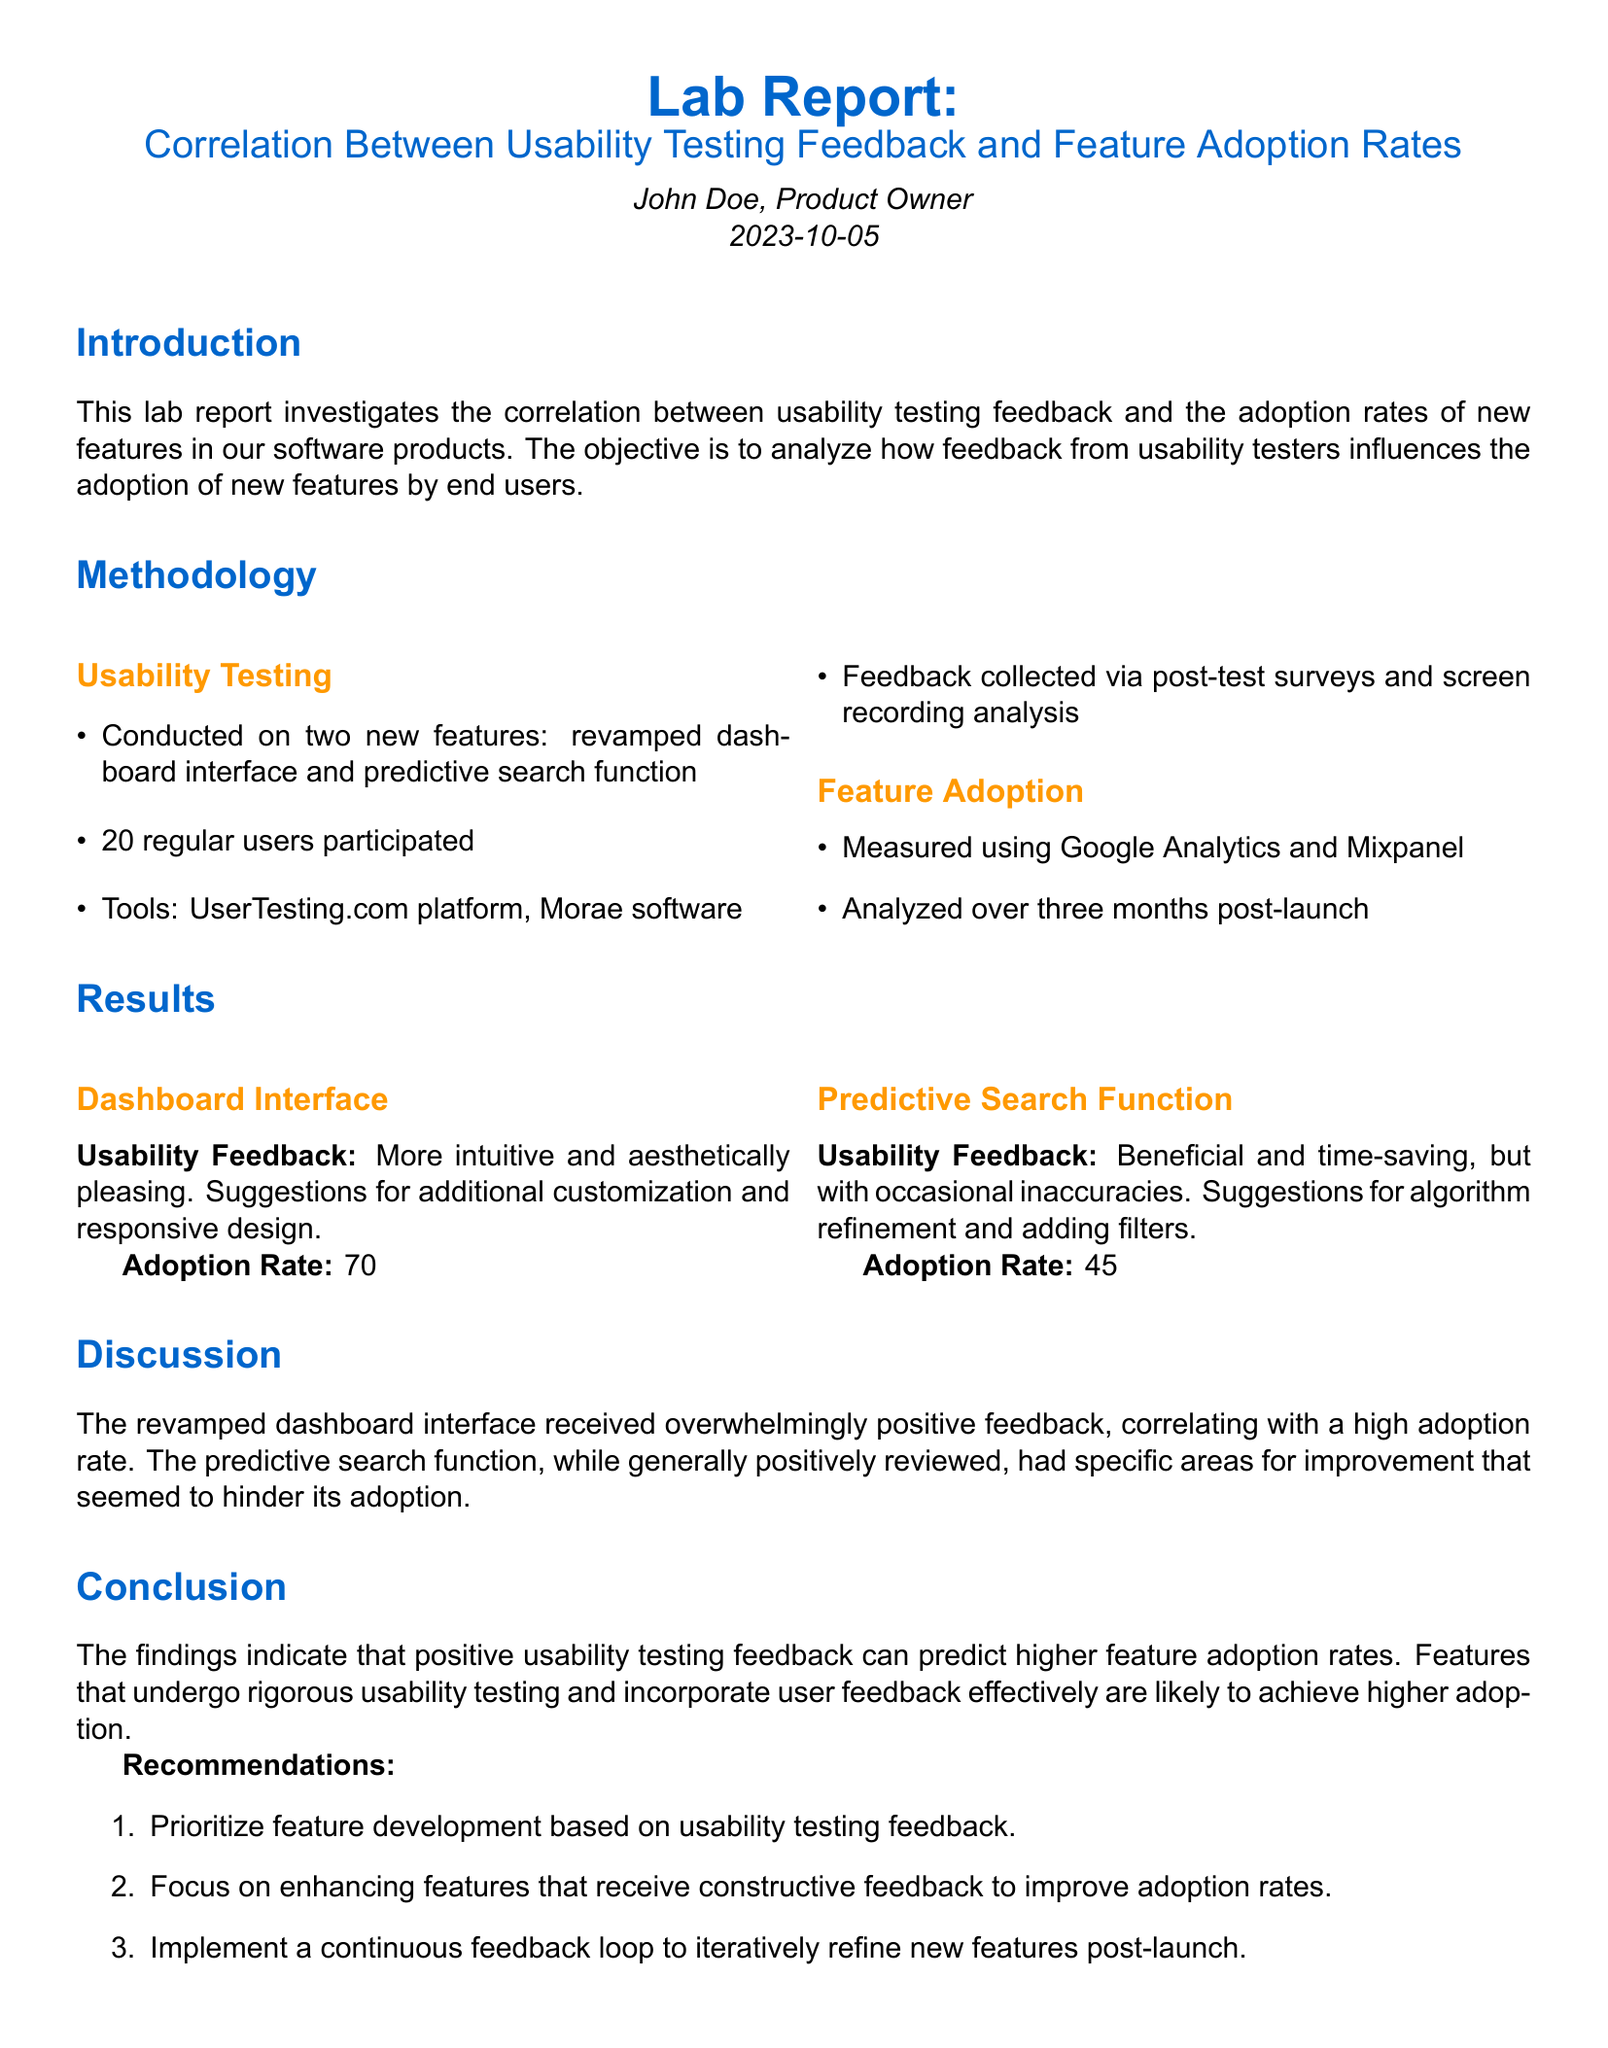What two features were tested? The document lists the two features as the revamped dashboard interface and predictive search function.
Answer: revamped dashboard interface and predictive search function What was the adoption rate for the dashboard interface in the first month? The adoption rate for the dashboard interface in the first month is stated as 70%.
Answer: 70% What percentage of users found the predictive search function beneficial? The document indicates that the predictive search function was described as beneficial, but it does not specify a percentage, so the answer should reflect that general sentiment.
Answer: beneficial What was the final adoption rate for the predictive search function by the third month? The final adoption rate for the predictive search function is stated as 55% by the third month.
Answer: 55% What improvement suggestion was made for the dashboard interface? The feedback included a suggestion for additional customization and responsive design for the dashboard interface.
Answer: additional customization and responsive design Which testing tool was used to collect feedback? The document mentions that UserTesting.com platform was one of the tools used to collect feedback.
Answer: UserTesting.com platform What is the main conclusion drawn from the results? The main conclusion is that positive usability testing feedback can predict higher feature adoption rates.
Answer: positive usability testing feedback can predict higher feature adoption rates What is one recommendation mentioned in the report? The report recommends prioritizing feature development based on usability testing feedback.
Answer: prioritize feature development based on usability testing feedback What type of data was analyzed alongside feature adoption? The document states that usability testing feedback was analyzed alongside feature adoption data.
Answer: usability testing feedback 